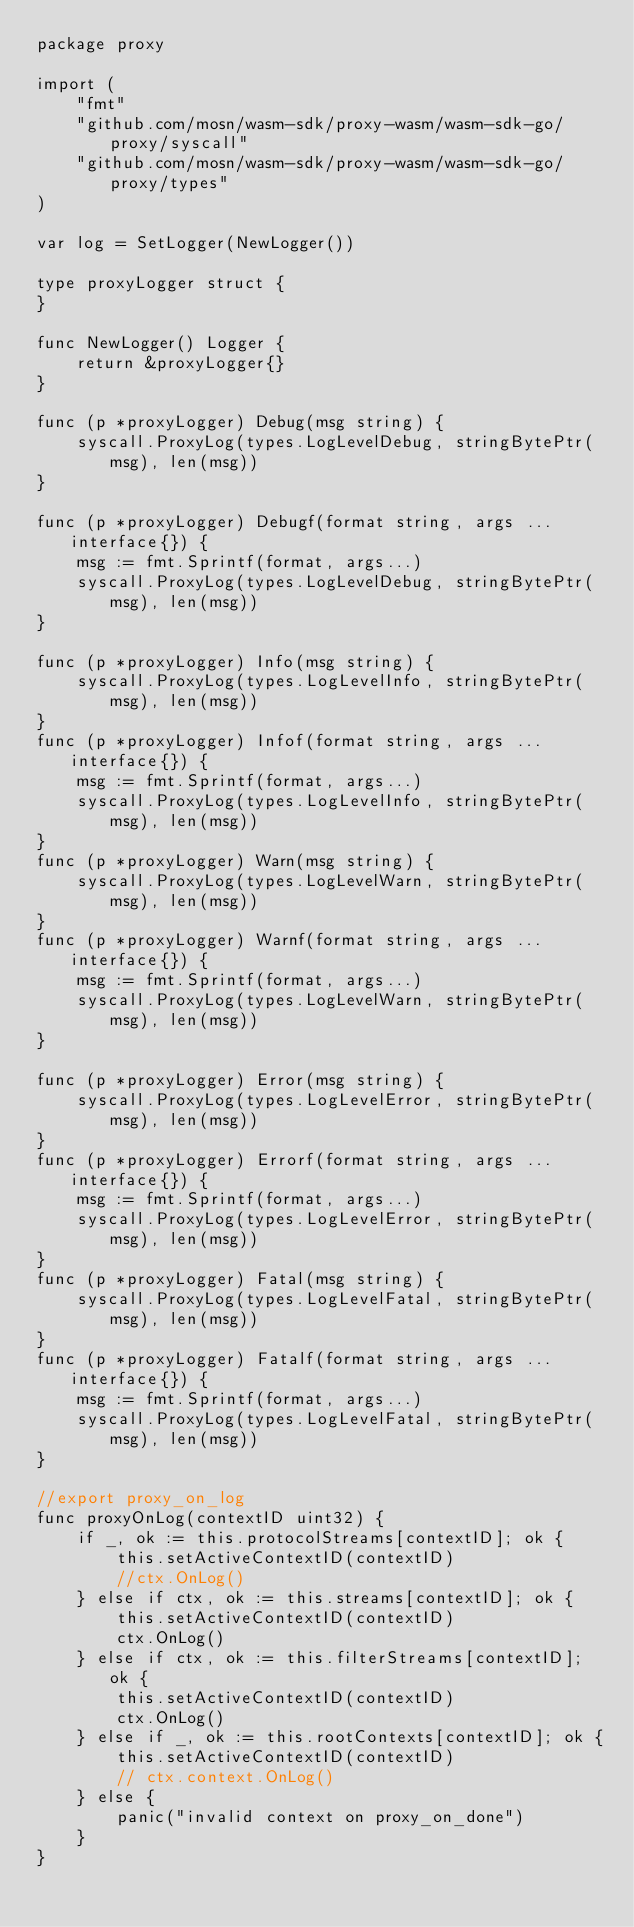Convert code to text. <code><loc_0><loc_0><loc_500><loc_500><_Go_>package proxy

import (
	"fmt"
	"github.com/mosn/wasm-sdk/proxy-wasm/wasm-sdk-go/proxy/syscall"
	"github.com/mosn/wasm-sdk/proxy-wasm/wasm-sdk-go/proxy/types"
)

var log = SetLogger(NewLogger())

type proxyLogger struct {
}

func NewLogger() Logger {
	return &proxyLogger{}
}

func (p *proxyLogger) Debug(msg string) {
	syscall.ProxyLog(types.LogLevelDebug, stringBytePtr(msg), len(msg))
}

func (p *proxyLogger) Debugf(format string, args ...interface{}) {
	msg := fmt.Sprintf(format, args...)
	syscall.ProxyLog(types.LogLevelDebug, stringBytePtr(msg), len(msg))
}

func (p *proxyLogger) Info(msg string) {
	syscall.ProxyLog(types.LogLevelInfo, stringBytePtr(msg), len(msg))
}
func (p *proxyLogger) Infof(format string, args ...interface{}) {
	msg := fmt.Sprintf(format, args...)
	syscall.ProxyLog(types.LogLevelInfo, stringBytePtr(msg), len(msg))
}
func (p *proxyLogger) Warn(msg string) {
	syscall.ProxyLog(types.LogLevelWarn, stringBytePtr(msg), len(msg))
}
func (p *proxyLogger) Warnf(format string, args ...interface{}) {
	msg := fmt.Sprintf(format, args...)
	syscall.ProxyLog(types.LogLevelWarn, stringBytePtr(msg), len(msg))
}

func (p *proxyLogger) Error(msg string) {
	syscall.ProxyLog(types.LogLevelError, stringBytePtr(msg), len(msg))
}
func (p *proxyLogger) Errorf(format string, args ...interface{}) {
	msg := fmt.Sprintf(format, args...)
	syscall.ProxyLog(types.LogLevelError, stringBytePtr(msg), len(msg))
}
func (p *proxyLogger) Fatal(msg string) {
	syscall.ProxyLog(types.LogLevelFatal, stringBytePtr(msg), len(msg))
}
func (p *proxyLogger) Fatalf(format string, args ...interface{}) {
	msg := fmt.Sprintf(format, args...)
	syscall.ProxyLog(types.LogLevelFatal, stringBytePtr(msg), len(msg))
}

//export proxy_on_log
func proxyOnLog(contextID uint32) {
	if _, ok := this.protocolStreams[contextID]; ok {
		this.setActiveContextID(contextID)
		//ctx.OnLog()
	} else if ctx, ok := this.streams[contextID]; ok {
		this.setActiveContextID(contextID)
		ctx.OnLog()
	} else if ctx, ok := this.filterStreams[contextID]; ok {
		this.setActiveContextID(contextID)
		ctx.OnLog()
	} else if _, ok := this.rootContexts[contextID]; ok {
		this.setActiveContextID(contextID)
		// ctx.context.OnLog()
	} else {
		panic("invalid context on proxy_on_done")
	}
}
</code> 